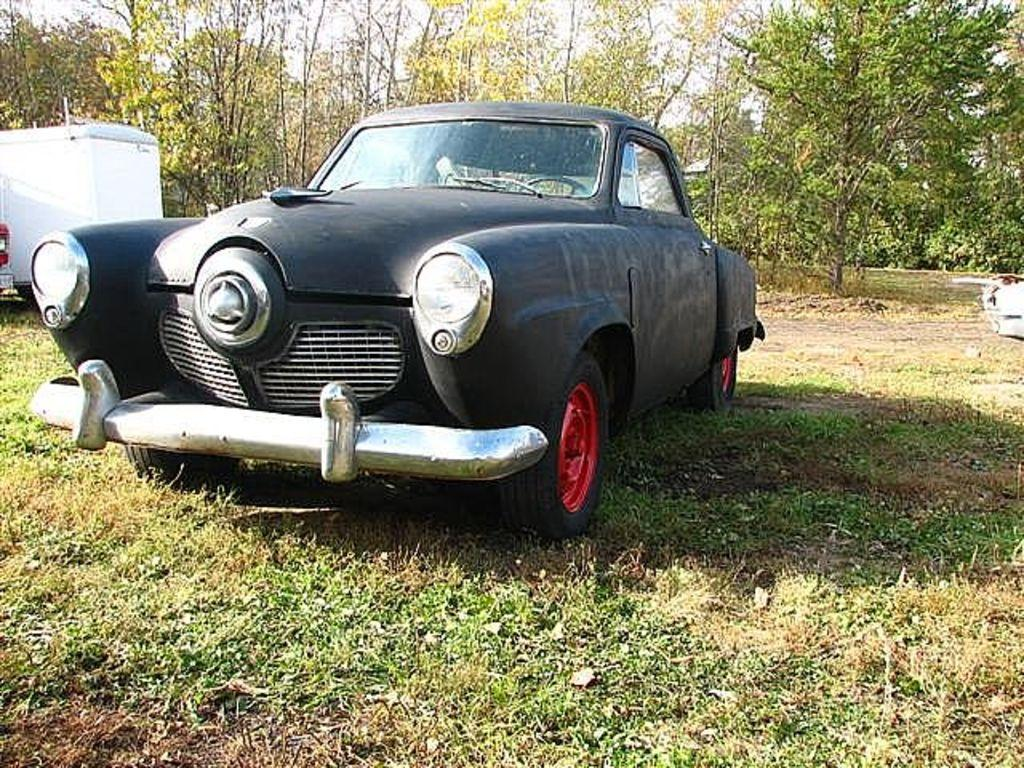What is the main subject in the foreground of the image? There is a car in the foreground of the image. What type of terrain is visible at the bottom of the image? There is grass at the bottom of the image. What can be seen in the background of the image? There are vehicles and trees in the background of the image. Can you see the moon in the image? There is no moon visible in the image; it features a car in the foreground, grass at the bottom, and vehicles and trees in the background. 